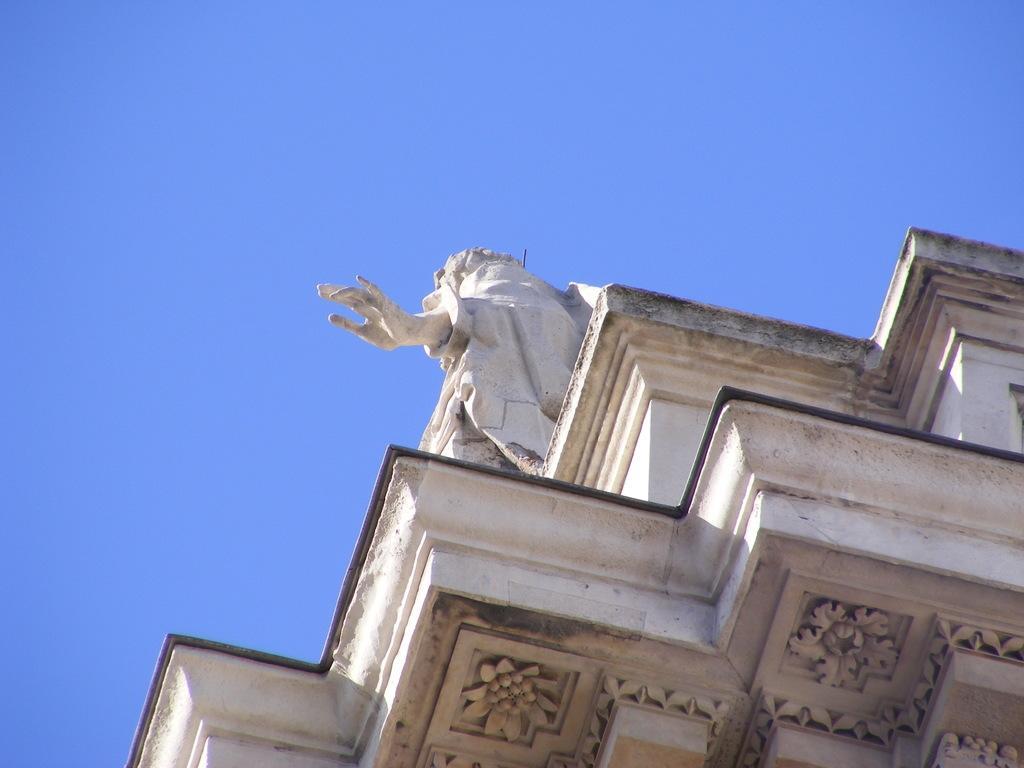Please provide a concise description of this image. In this image we can see a part of a building with sculptures. In the background there is sky. 